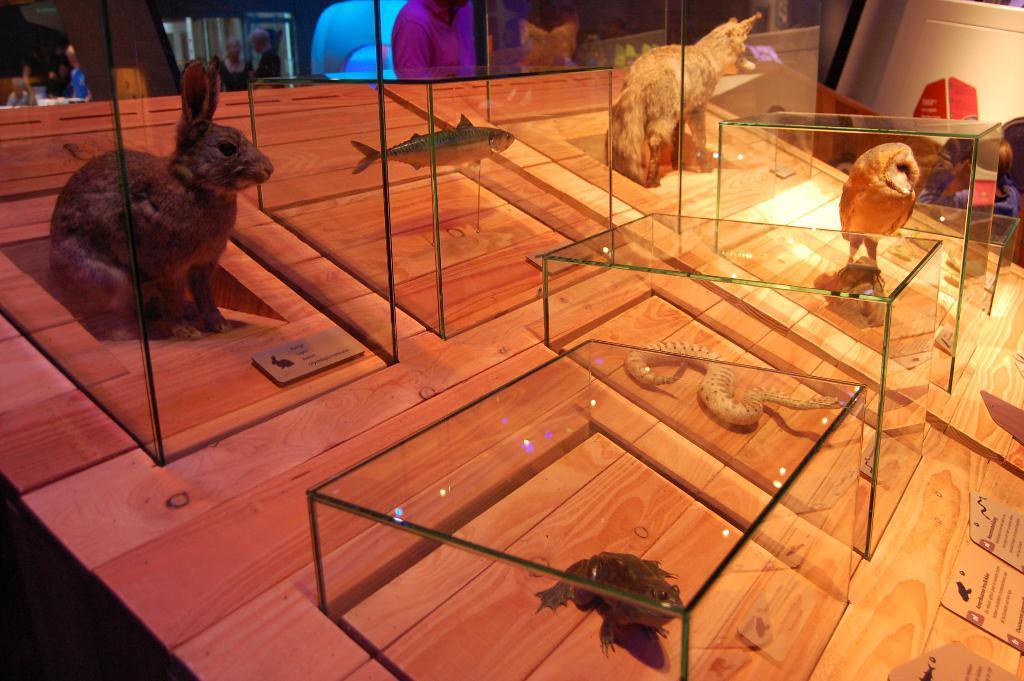Describe this image in one or two sentences. In this image I can see the wooden board and on the board I can see few glass boxes with animals in them. 